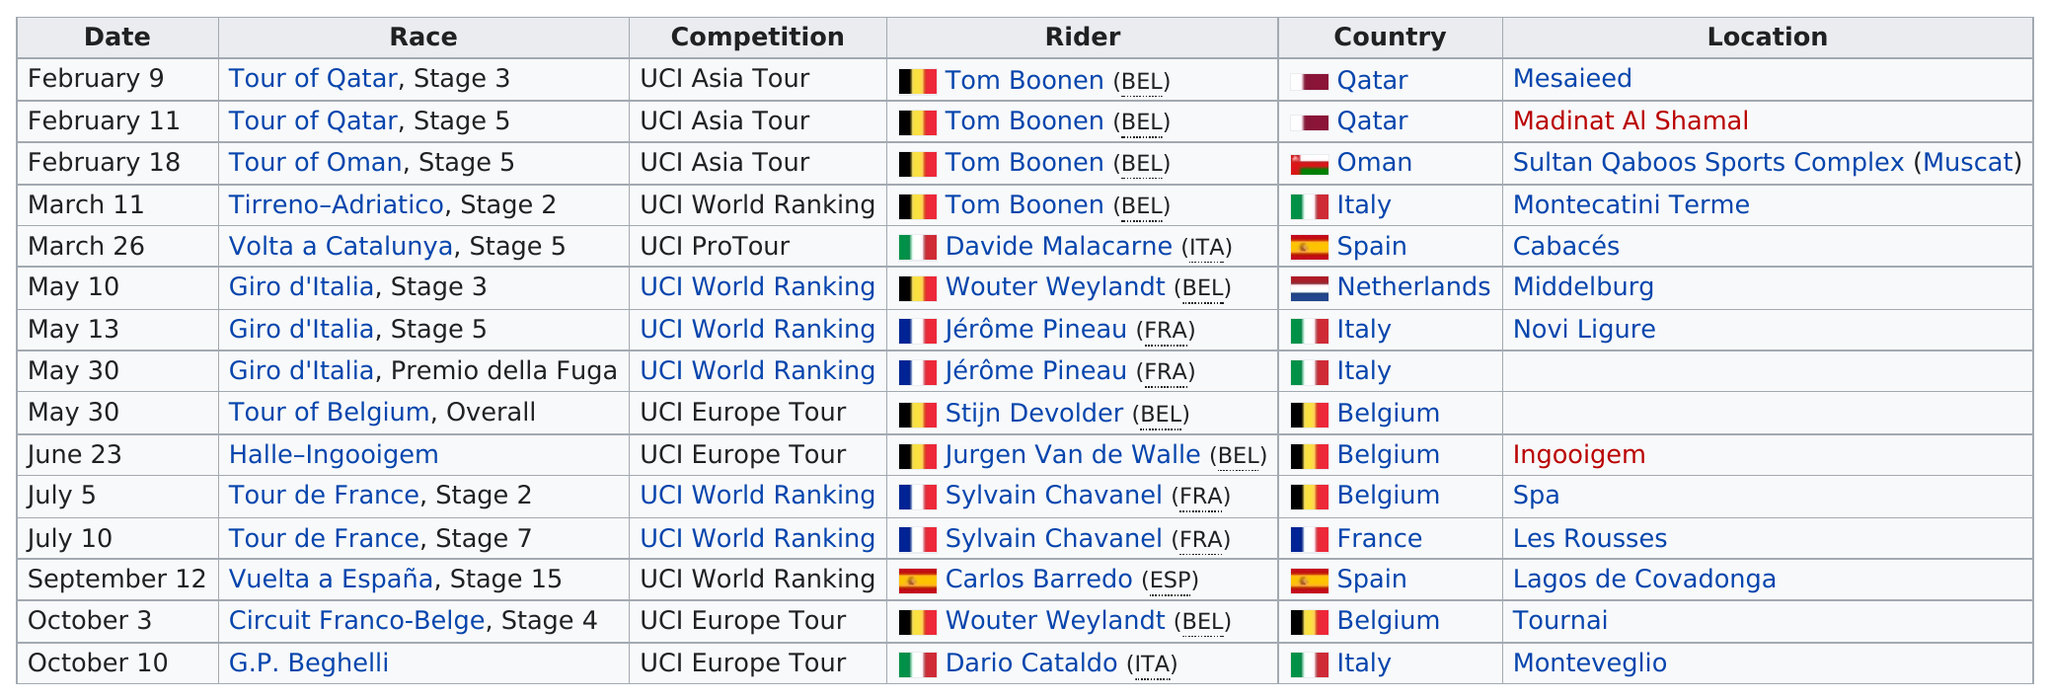Highlight a few significant elements in this photo. Tom Boonen won a total of 4 races. Tom Boonen won two consecutive stages at the Tour of Qatar. Tom Boonen has a total of 4 wins overall. Tom Boonen was listed as the rider a total of four times. There are 4 UCI Europe Tour competitions recorded in the chart. 